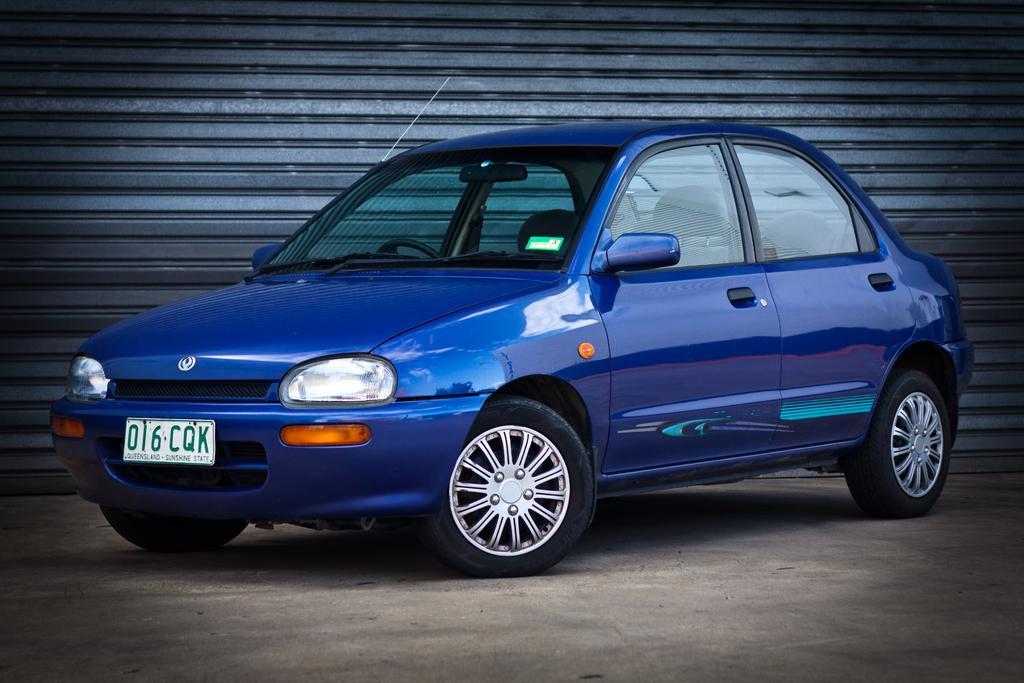How would you summarize this image in a sentence or two? In the image we can see a car, blue in color. These are the headlights and number plate of the vehicle. Here we can see a road and the shutter. 